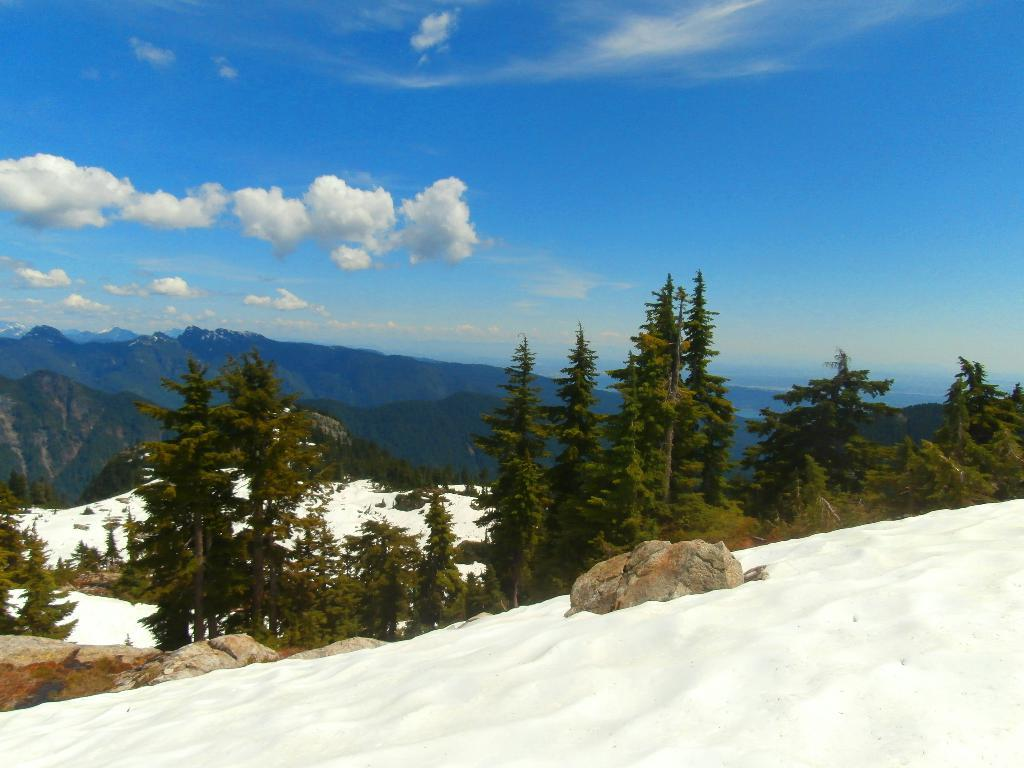What is the main feature in the foreground of the image? There is a snow surface in the foreground of the image. What type of vegetation is visible behind the snow surface? There are trees behind the snow surface. What geographical feature can be seen in the background of the image? There are mountains visible in the background of the image. What type of veil is draped over the trees in the image? There is no veil present in the image; the trees are not covered by any fabric or material. 